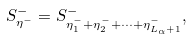<formula> <loc_0><loc_0><loc_500><loc_500>S _ { \eta ^ { - } } ^ { - } = S _ { \eta _ { 1 } ^ { - } + \eta _ { 2 } ^ { - } + \dots + \eta _ { L _ { \alpha } + 1 } ^ { - } } ^ { - } ,</formula> 